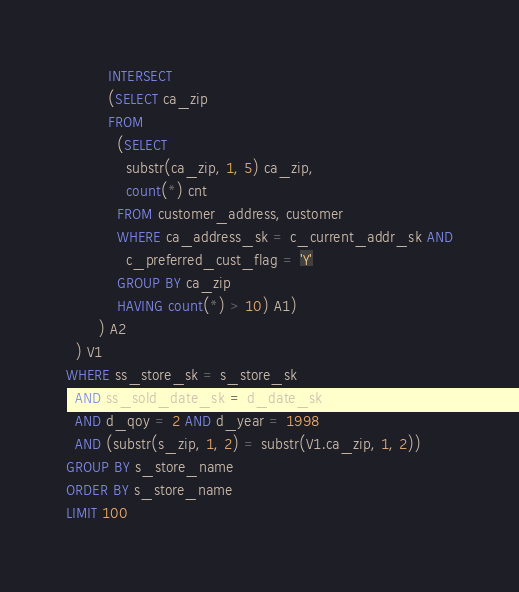<code> <loc_0><loc_0><loc_500><loc_500><_SQL_>         INTERSECT
         (SELECT ca_zip
         FROM
           (SELECT
             substr(ca_zip, 1, 5) ca_zip,
             count(*) cnt
           FROM customer_address, customer
           WHERE ca_address_sk = c_current_addr_sk AND
             c_preferred_cust_flag = 'Y'
           GROUP BY ca_zip
           HAVING count(*) > 10) A1)
       ) A2
  ) V1
WHERE ss_store_sk = s_store_sk
  AND ss_sold_date_sk = d_date_sk
  AND d_qoy = 2 AND d_year = 1998
  AND (substr(s_zip, 1, 2) = substr(V1.ca_zip, 1, 2))
GROUP BY s_store_name
ORDER BY s_store_name
LIMIT 100
</code> 